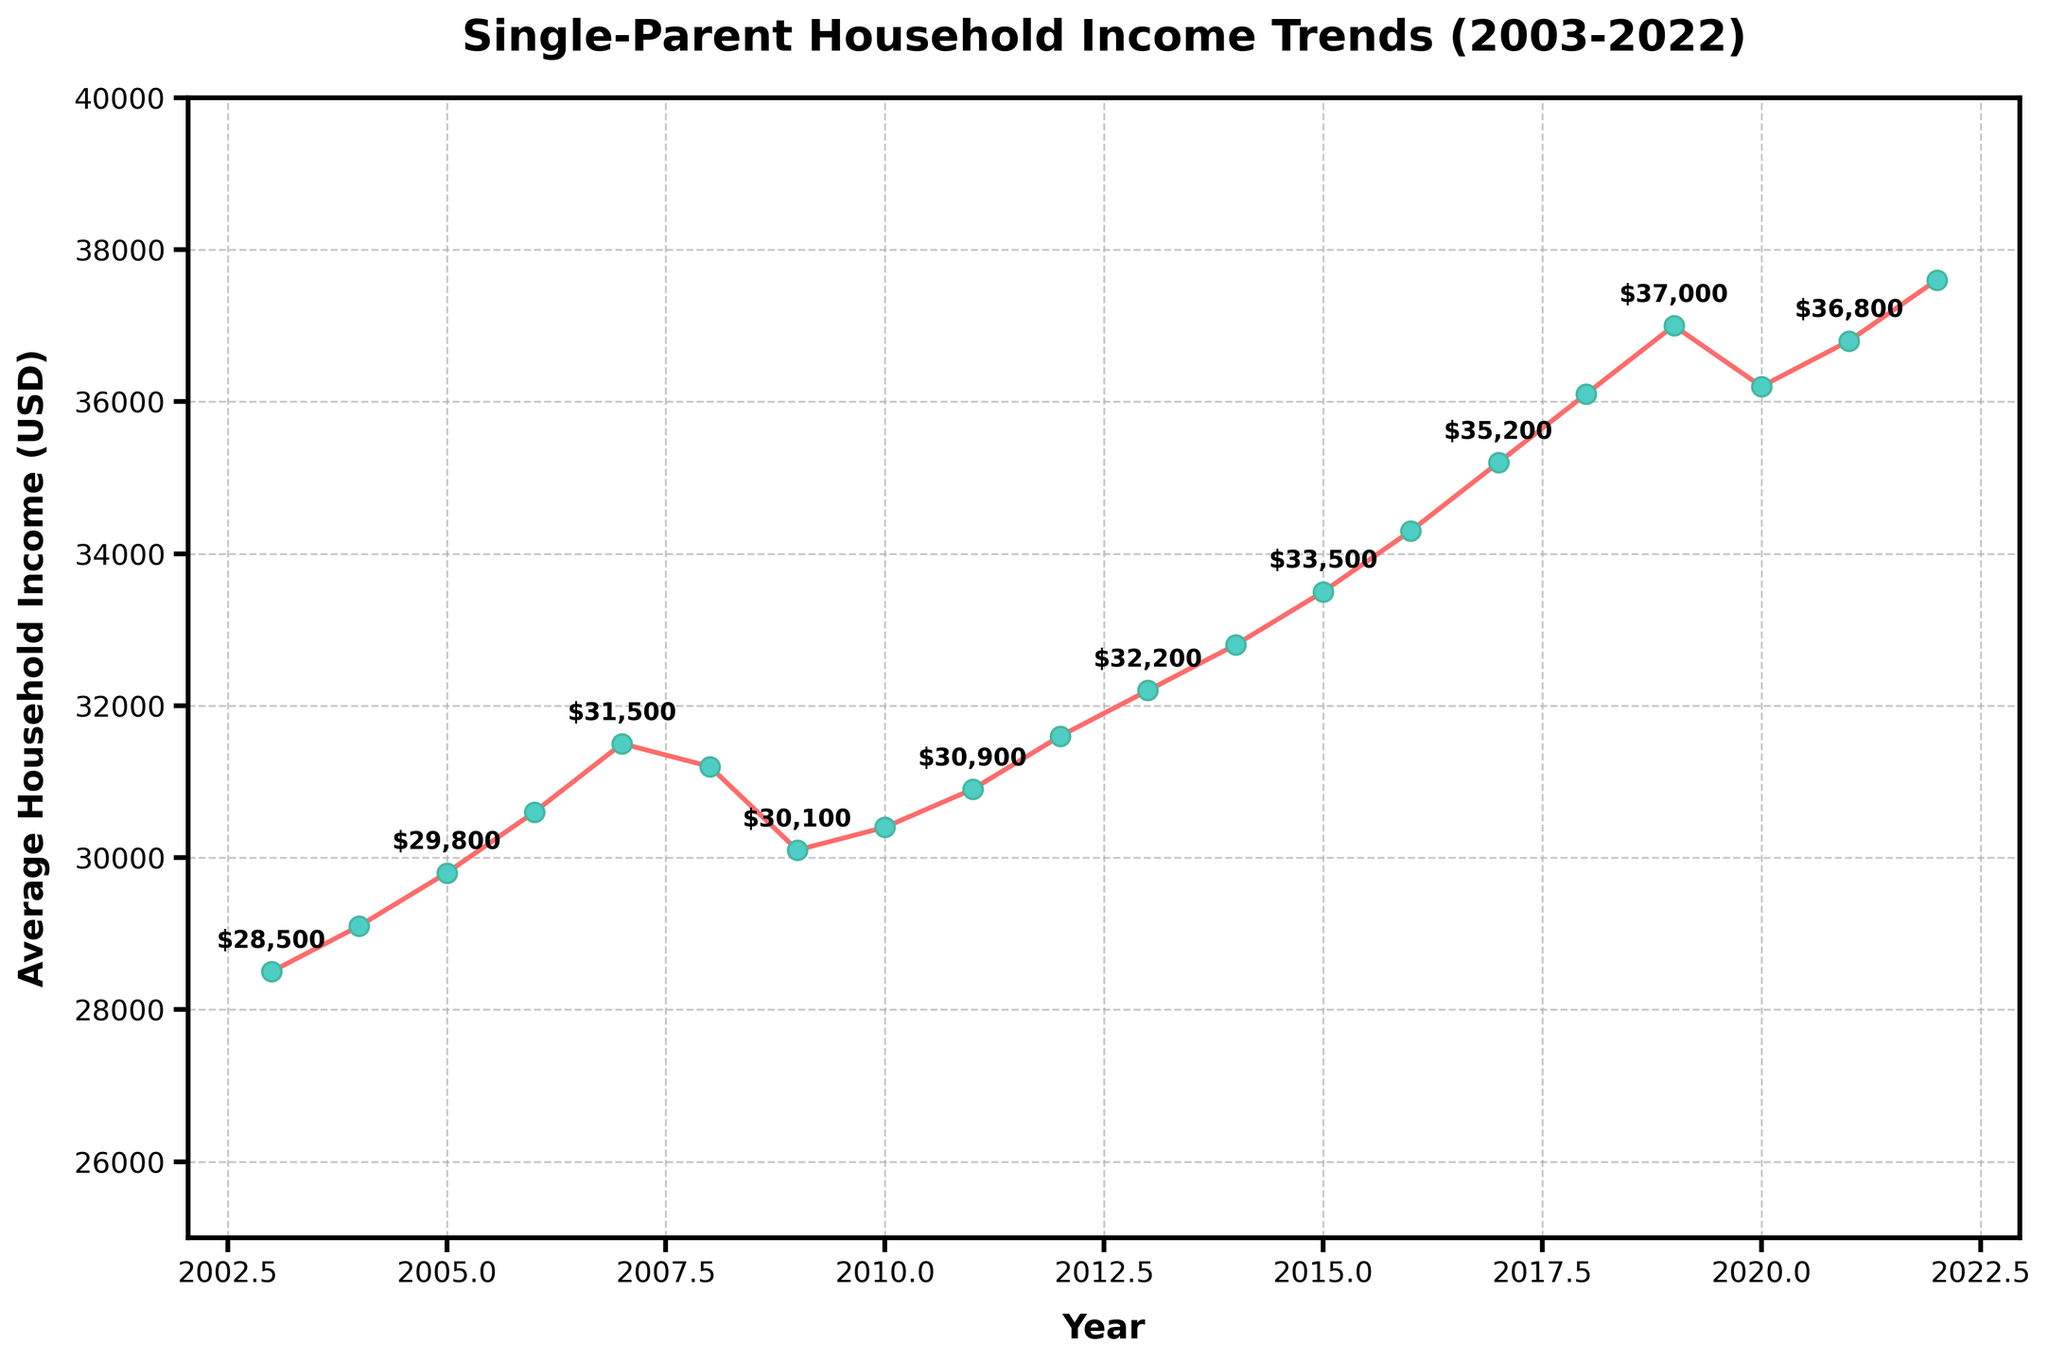What is the overall trend in average household income for single-parent families from 2003 to 2022? The overall trend is determined by observing the direction of income changes over the years. The average household income steadily increases from 2003 to 2022 with a slight dip around 2008-2009 and 2020.
Answer: Increasing Which year had the highest average household income for single-parent families? Locate the peak point on the plot to identify the year with the highest income. The highest average household income is noted in 2022.
Answer: 2022 How does the income in 2020 compare to the income in 2019? Find the 2020 and 2019 data points and compare their values. The income in 2020 ($36,200) is lower than the income in 2019 ($37,000).
Answer: 2020 is lower What are the average household incomes for 2008 and 2012, and what is the difference between them? Identify the incomes for 2008 ($31,200) and 2012 ($31,600) and calculate the difference: $31,600 - $31,200 = $400.
Answer: $400 difference During which period did the average household income decrease and then increase again? Examine the plot for decreases followed by increases. The period from 2007 to 2009 shows a decrease from $31,500 to $30,100 followed by recovery in 2010 to $30,400.
Answer: 2007 to 2010 Which year showed the quickest growth in average household income compared to the previous year? Determine the differences between each consecutive year, and find the maximum change. The largest increase happens between 2018 ($36,100) and 2019 ($37,000), amounting to $900 growth.
Answer: 2019 By how much did the average household income change from 2016 to 2022? Identify the incomes in 2016 ($34,300) and 2022 ($37,600), then calculate the difference: $37,600 - $34,300 = $3,300.
Answer: $3,300 What visual characteristics highlight the years with income values annotated? Visual annotations are added every other year; these values are marked with labels above the data points and have distinctive markers.
Answer: Every other year marked What is the general income trend before and after the Great Recession (2008-2009)? Identify the trendline before and after 2008-2009. Before the recession, the income generally increased, but there was a dip around 2008-2009, followed by a gradual recovery and increase post-recession.
Answer: Dip, then recovery What was the percentage increase in average household income from 2003 to 2022? To find the percentage increase: ((Final value - Initial value) / Initial value) * 100. Initial (2003) = $28,500, Final (2022) = $37,600. Calculation: (($37,600 - $28,500) / $28,500) * 100 ≈ 32%.
Answer: 32% 